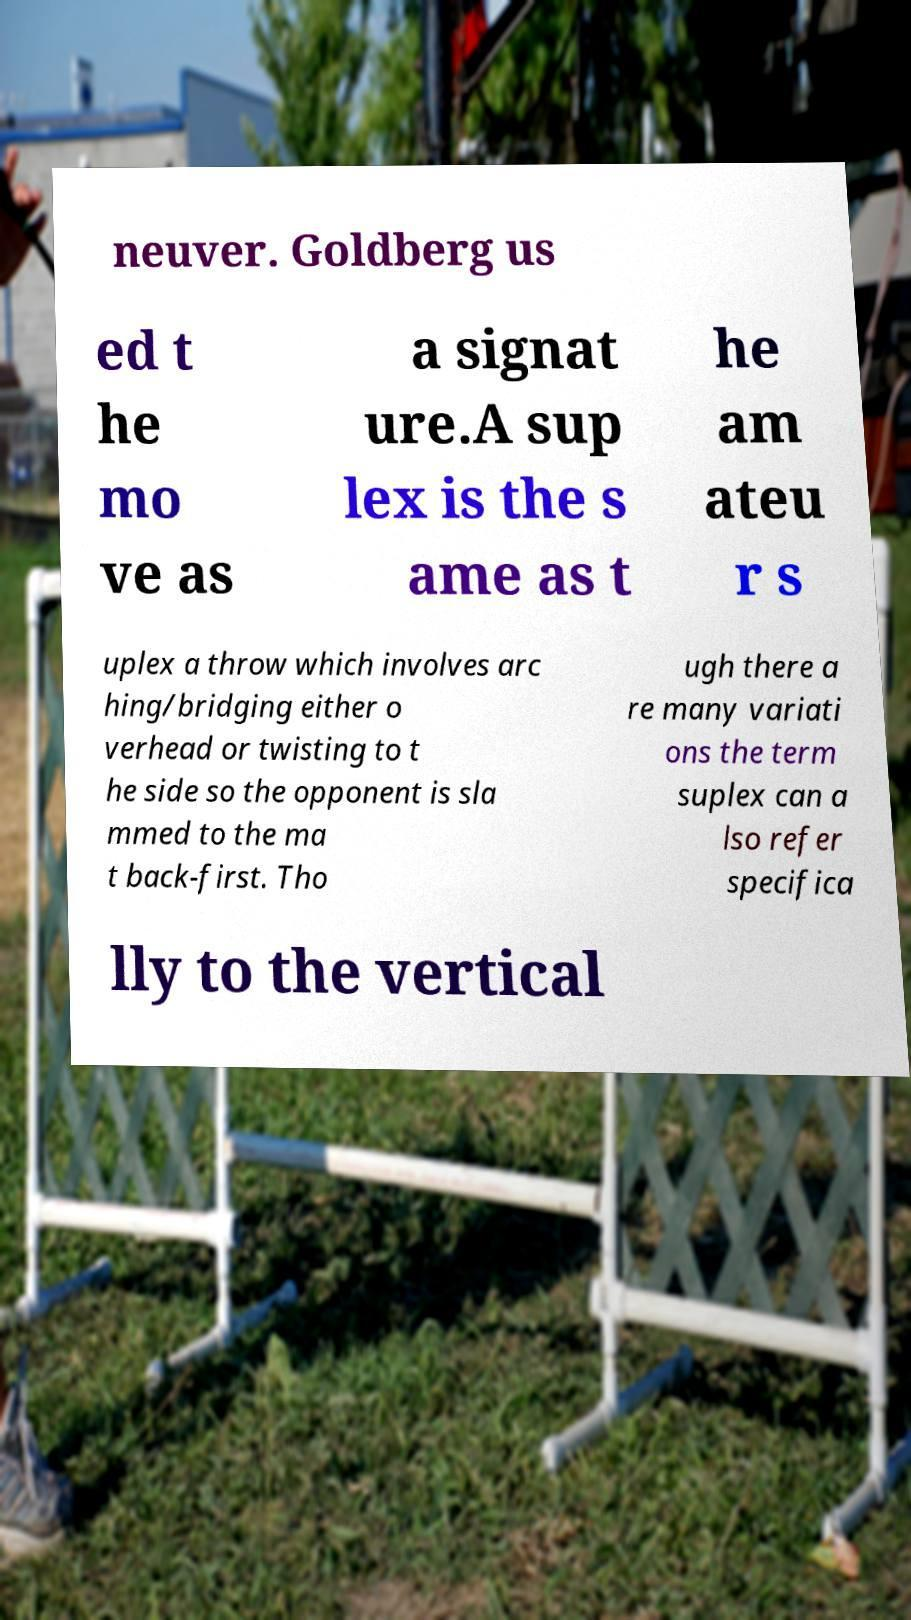Could you extract and type out the text from this image? neuver. Goldberg us ed t he mo ve as a signat ure.A sup lex is the s ame as t he am ateu r s uplex a throw which involves arc hing/bridging either o verhead or twisting to t he side so the opponent is sla mmed to the ma t back-first. Tho ugh there a re many variati ons the term suplex can a lso refer specifica lly to the vertical 